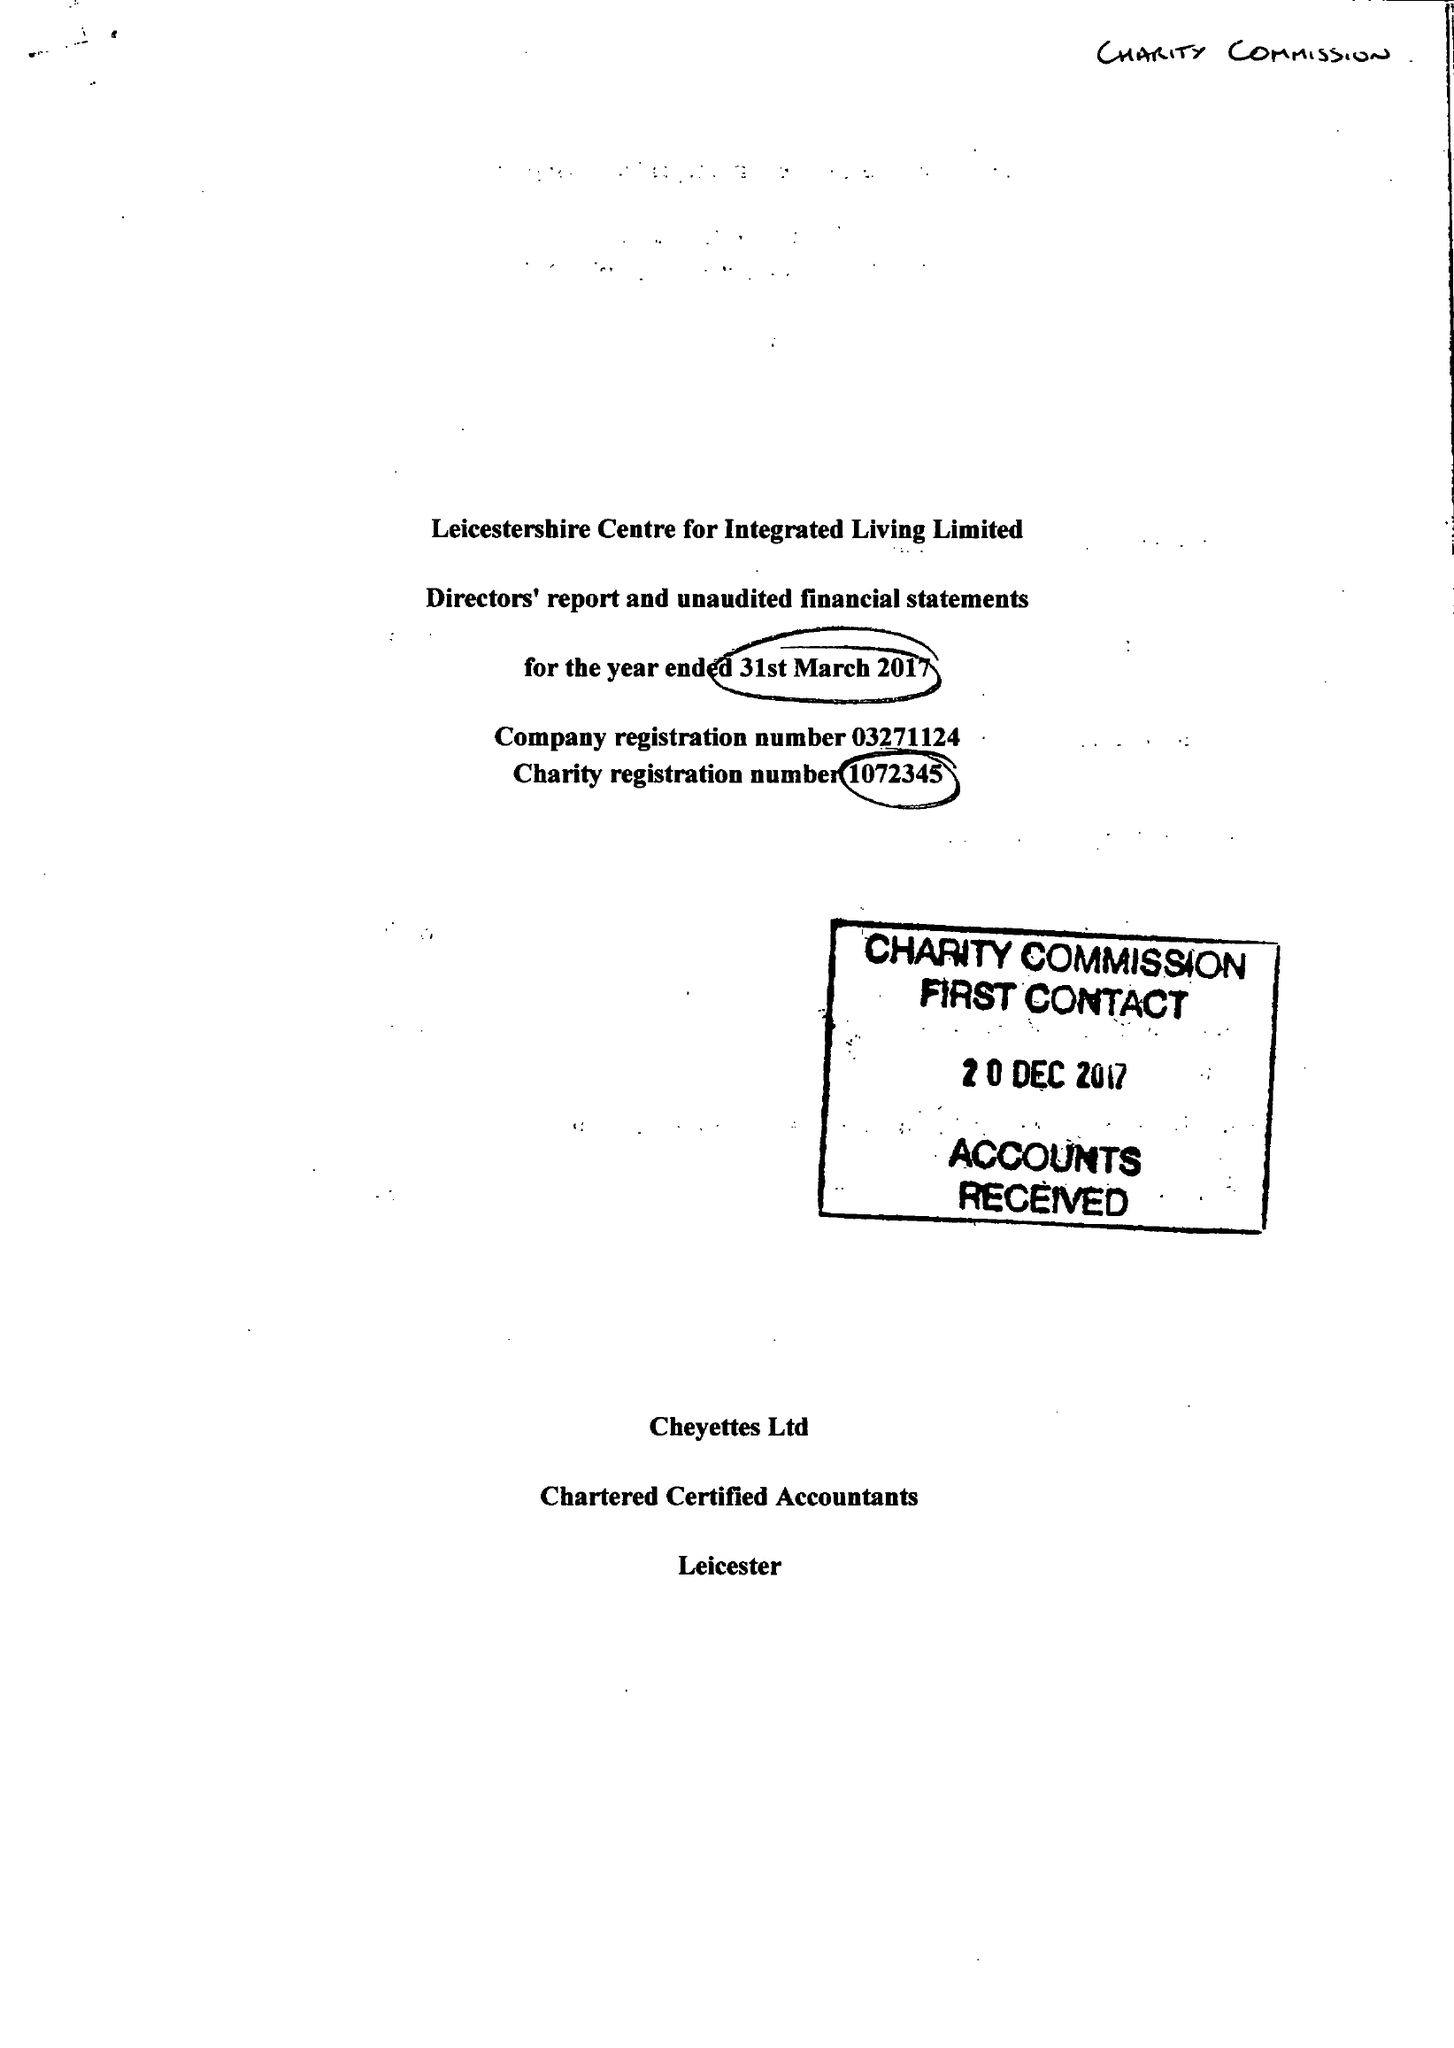What is the value for the charity_number?
Answer the question using a single word or phrase. 1072345 